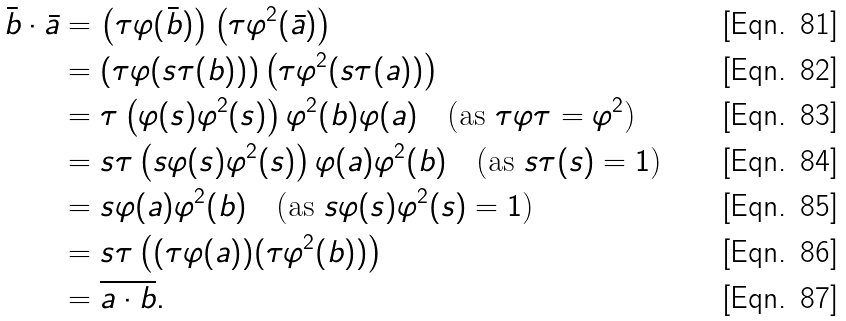Convert formula to latex. <formula><loc_0><loc_0><loc_500><loc_500>\bar { b } \cdot \bar { a } & = \left ( \tau \varphi ( \bar { b } ) \right ) \left ( \tau \varphi ^ { 2 } ( \bar { a } ) \right ) \\ & = \left ( \tau \varphi ( s \tau ( b ) ) \right ) \left ( \tau \varphi ^ { 2 } ( s \tau ( a ) ) \right ) \\ & = \tau \left ( \varphi ( s ) \varphi ^ { 2 } ( s ) \right ) \varphi ^ { 2 } ( b ) \varphi ( a ) \quad \text {(as $\tau\varphi\tau=\varphi^{2}$)} \\ & = s \tau \left ( s \varphi ( s ) \varphi ^ { 2 } ( s ) \right ) \varphi ( a ) \varphi ^ { 2 } ( b ) \quad \text {(as $s\tau(s)=1$)} \\ & = s \varphi ( a ) \varphi ^ { 2 } ( b ) \quad \text {(as $s\varphi(s)\varphi^{2}(s)=1$)} \\ & = s \tau \left ( ( \tau \varphi ( a ) ) ( \tau \varphi ^ { 2 } ( b ) ) \right ) \\ & = \overline { a \cdot b } .</formula> 